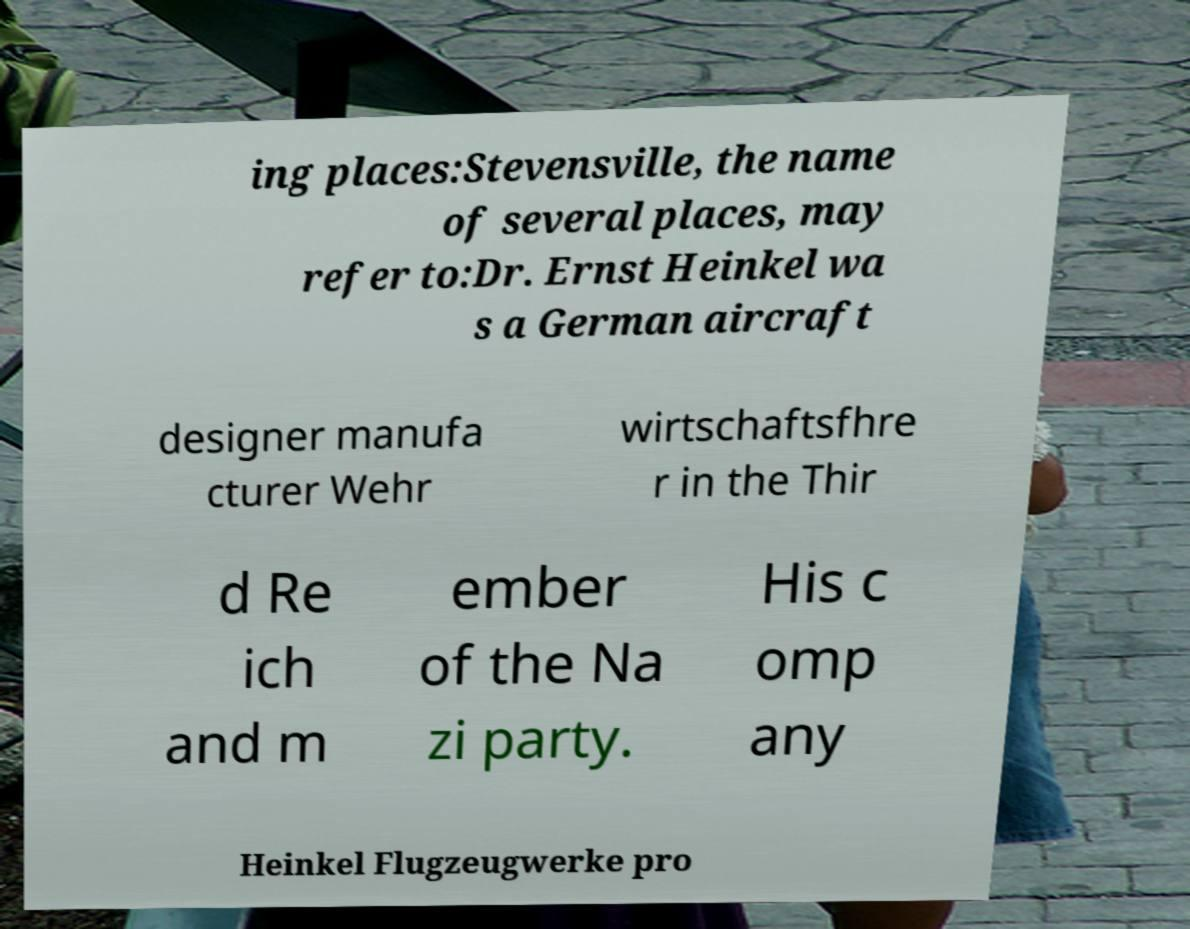What messages or text are displayed in this image? I need them in a readable, typed format. ing places:Stevensville, the name of several places, may refer to:Dr. Ernst Heinkel wa s a German aircraft designer manufa cturer Wehr wirtschaftsfhre r in the Thir d Re ich and m ember of the Na zi party. His c omp any Heinkel Flugzeugwerke pro 